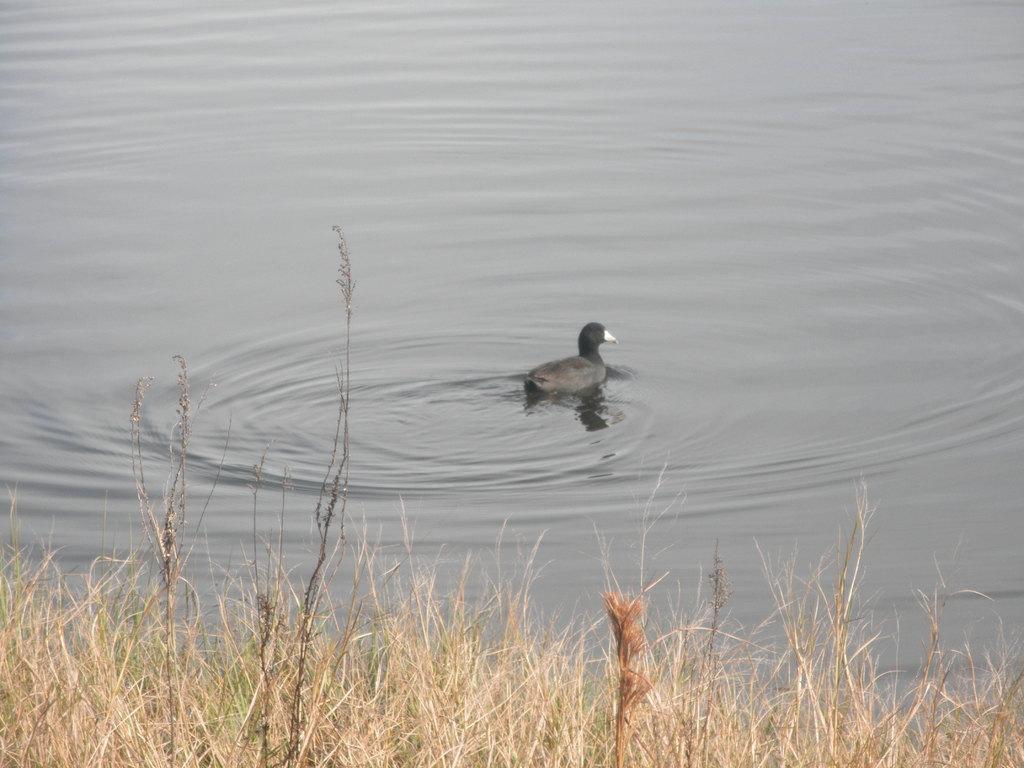Describe this image in one or two sentences. In this image I can see grass in the front and in the background I can see water. In the centre of this image I can see a black colour bird on the water. 